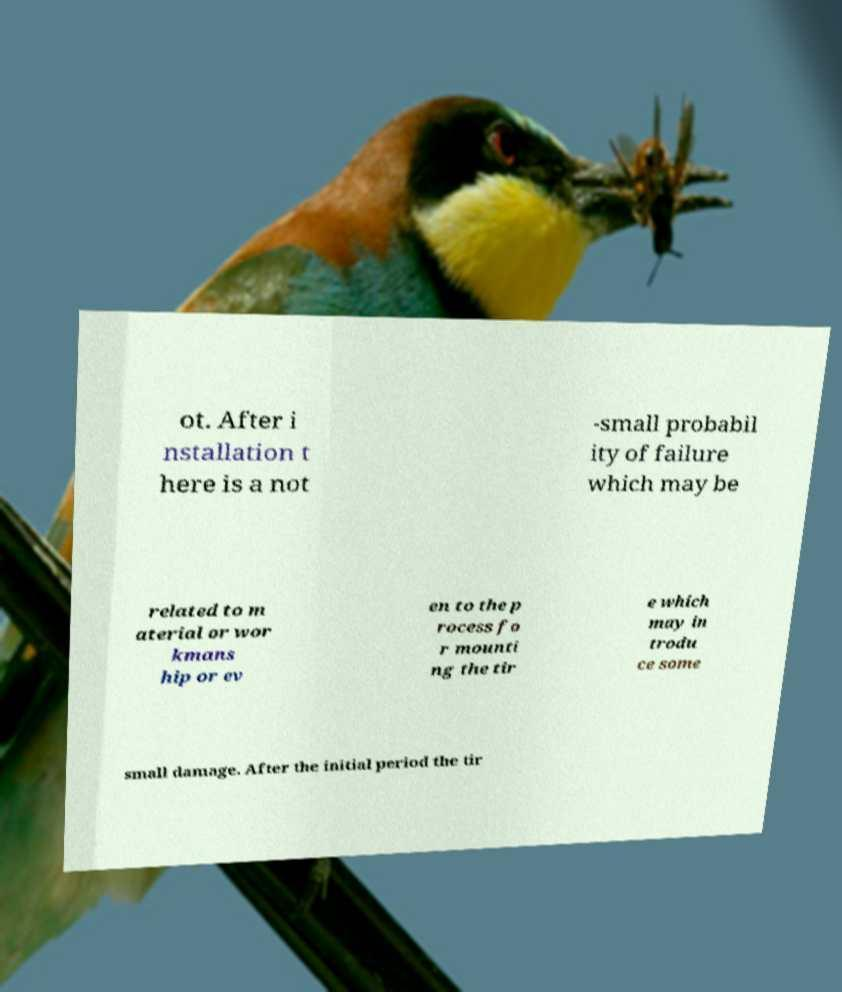Could you assist in decoding the text presented in this image and type it out clearly? ot. After i nstallation t here is a not -small probabil ity of failure which may be related to m aterial or wor kmans hip or ev en to the p rocess fo r mounti ng the tir e which may in trodu ce some small damage. After the initial period the tir 